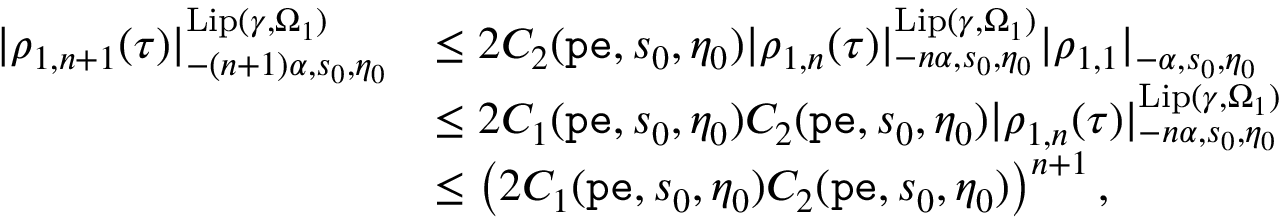Convert formula to latex. <formula><loc_0><loc_0><loc_500><loc_500>\begin{array} { r l } { | \rho _ { 1 , n + 1 } ( \tau ) | _ { - ( n + 1 ) \alpha , s _ { 0 } , \eta _ { 0 } } ^ { L i p ( \gamma , \Omega _ { 1 } ) } } & { \leq 2 C _ { 2 } ( p e , s _ { 0 } , \eta _ { 0 } ) | { \rho _ { 1 , n } } ( \tau ) | _ { - n \alpha , s _ { 0 } , \eta _ { 0 } } ^ { L i p ( \gamma , \Omega _ { 1 } ) } | \rho _ { 1 , 1 } | _ { - \alpha , s _ { 0 } , \eta _ { 0 } } } \\ & { \leq 2 C _ { 1 } ( p e , s _ { 0 } , \eta _ { 0 } ) C _ { 2 } ( p e , s _ { 0 } , \eta _ { 0 } ) | \rho _ { 1 , n } ( \tau ) | _ { - n \alpha , s _ { 0 } , \eta _ { 0 } } ^ { L i p ( \gamma , \Omega _ { 1 } ) } } \\ & { \leq \left ( 2 C _ { 1 } ( p e , s _ { 0 } , \eta _ { 0 } ) C _ { 2 } ( p e , s _ { 0 } , \eta _ { 0 } ) \right ) ^ { n + 1 } , } \end{array}</formula> 